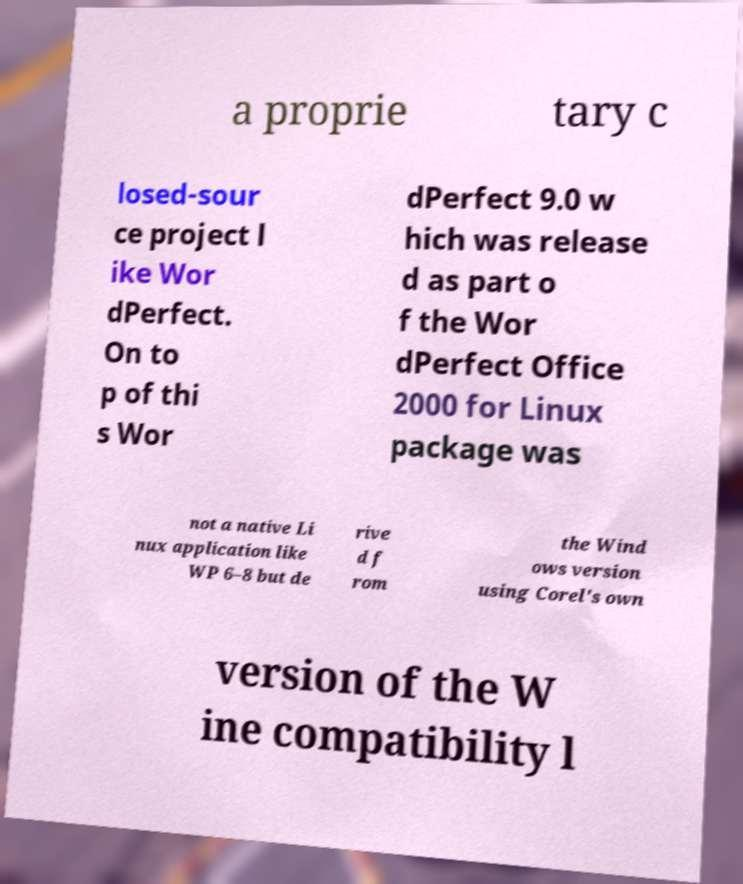There's text embedded in this image that I need extracted. Can you transcribe it verbatim? a proprie tary c losed-sour ce project l ike Wor dPerfect. On to p of thi s Wor dPerfect 9.0 w hich was release d as part o f the Wor dPerfect Office 2000 for Linux package was not a native Li nux application like WP 6–8 but de rive d f rom the Wind ows version using Corel's own version of the W ine compatibility l 